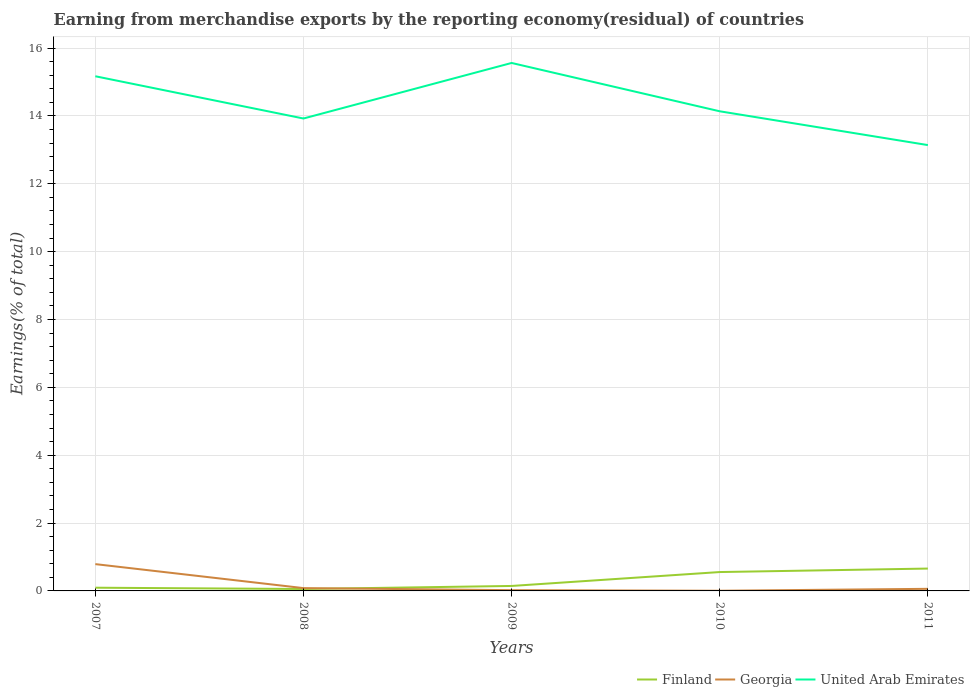How many different coloured lines are there?
Ensure brevity in your answer.  3. Does the line corresponding to United Arab Emirates intersect with the line corresponding to Finland?
Your response must be concise. No. Across all years, what is the maximum percentage of amount earned from merchandise exports in Georgia?
Your answer should be compact. 0.01. What is the total percentage of amount earned from merchandise exports in United Arab Emirates in the graph?
Make the answer very short. 2.42. What is the difference between the highest and the second highest percentage of amount earned from merchandise exports in Finland?
Make the answer very short. 0.6. How many lines are there?
Ensure brevity in your answer.  3. Are the values on the major ticks of Y-axis written in scientific E-notation?
Offer a terse response. No. Does the graph contain any zero values?
Your answer should be very brief. No. Does the graph contain grids?
Offer a very short reply. Yes. Where does the legend appear in the graph?
Make the answer very short. Bottom right. How are the legend labels stacked?
Ensure brevity in your answer.  Horizontal. What is the title of the graph?
Your answer should be very brief. Earning from merchandise exports by the reporting economy(residual) of countries. Does "Andorra" appear as one of the legend labels in the graph?
Ensure brevity in your answer.  No. What is the label or title of the Y-axis?
Your answer should be very brief. Earnings(% of total). What is the Earnings(% of total) of Finland in 2007?
Offer a terse response. 0.09. What is the Earnings(% of total) of Georgia in 2007?
Provide a succinct answer. 0.79. What is the Earnings(% of total) in United Arab Emirates in 2007?
Make the answer very short. 15.17. What is the Earnings(% of total) of Finland in 2008?
Provide a short and direct response. 0.06. What is the Earnings(% of total) in Georgia in 2008?
Your response must be concise. 0.08. What is the Earnings(% of total) in United Arab Emirates in 2008?
Give a very brief answer. 13.92. What is the Earnings(% of total) of Finland in 2009?
Your answer should be compact. 0.15. What is the Earnings(% of total) of Georgia in 2009?
Give a very brief answer. 0.02. What is the Earnings(% of total) of United Arab Emirates in 2009?
Your answer should be compact. 15.56. What is the Earnings(% of total) in Finland in 2010?
Ensure brevity in your answer.  0.56. What is the Earnings(% of total) of Georgia in 2010?
Ensure brevity in your answer.  0.01. What is the Earnings(% of total) in United Arab Emirates in 2010?
Give a very brief answer. 14.14. What is the Earnings(% of total) in Finland in 2011?
Offer a very short reply. 0.66. What is the Earnings(% of total) in Georgia in 2011?
Your answer should be very brief. 0.06. What is the Earnings(% of total) in United Arab Emirates in 2011?
Make the answer very short. 13.14. Across all years, what is the maximum Earnings(% of total) in Finland?
Give a very brief answer. 0.66. Across all years, what is the maximum Earnings(% of total) in Georgia?
Make the answer very short. 0.79. Across all years, what is the maximum Earnings(% of total) in United Arab Emirates?
Make the answer very short. 15.56. Across all years, what is the minimum Earnings(% of total) in Finland?
Keep it short and to the point. 0.06. Across all years, what is the minimum Earnings(% of total) in Georgia?
Keep it short and to the point. 0.01. Across all years, what is the minimum Earnings(% of total) of United Arab Emirates?
Offer a terse response. 13.14. What is the total Earnings(% of total) in Finland in the graph?
Keep it short and to the point. 1.51. What is the total Earnings(% of total) in Georgia in the graph?
Give a very brief answer. 0.96. What is the total Earnings(% of total) of United Arab Emirates in the graph?
Give a very brief answer. 71.92. What is the difference between the Earnings(% of total) in Finland in 2007 and that in 2008?
Give a very brief answer. 0.04. What is the difference between the Earnings(% of total) of Georgia in 2007 and that in 2008?
Your response must be concise. 0.71. What is the difference between the Earnings(% of total) in United Arab Emirates in 2007 and that in 2008?
Provide a succinct answer. 1.25. What is the difference between the Earnings(% of total) of Finland in 2007 and that in 2009?
Provide a short and direct response. -0.05. What is the difference between the Earnings(% of total) of Georgia in 2007 and that in 2009?
Provide a succinct answer. 0.77. What is the difference between the Earnings(% of total) in United Arab Emirates in 2007 and that in 2009?
Give a very brief answer. -0.39. What is the difference between the Earnings(% of total) in Finland in 2007 and that in 2010?
Your answer should be very brief. -0.46. What is the difference between the Earnings(% of total) of Georgia in 2007 and that in 2010?
Your answer should be compact. 0.78. What is the difference between the Earnings(% of total) of United Arab Emirates in 2007 and that in 2010?
Make the answer very short. 1.03. What is the difference between the Earnings(% of total) of Finland in 2007 and that in 2011?
Ensure brevity in your answer.  -0.56. What is the difference between the Earnings(% of total) in Georgia in 2007 and that in 2011?
Offer a terse response. 0.73. What is the difference between the Earnings(% of total) of United Arab Emirates in 2007 and that in 2011?
Your answer should be compact. 2.03. What is the difference between the Earnings(% of total) of Finland in 2008 and that in 2009?
Your answer should be compact. -0.09. What is the difference between the Earnings(% of total) of Georgia in 2008 and that in 2009?
Keep it short and to the point. 0.06. What is the difference between the Earnings(% of total) of United Arab Emirates in 2008 and that in 2009?
Your answer should be very brief. -1.64. What is the difference between the Earnings(% of total) of Finland in 2008 and that in 2010?
Your answer should be very brief. -0.5. What is the difference between the Earnings(% of total) in Georgia in 2008 and that in 2010?
Provide a short and direct response. 0.08. What is the difference between the Earnings(% of total) of United Arab Emirates in 2008 and that in 2010?
Provide a short and direct response. -0.21. What is the difference between the Earnings(% of total) of Finland in 2008 and that in 2011?
Give a very brief answer. -0.6. What is the difference between the Earnings(% of total) in Georgia in 2008 and that in 2011?
Provide a short and direct response. 0.02. What is the difference between the Earnings(% of total) of United Arab Emirates in 2008 and that in 2011?
Offer a terse response. 0.78. What is the difference between the Earnings(% of total) of Finland in 2009 and that in 2010?
Make the answer very short. -0.41. What is the difference between the Earnings(% of total) in Georgia in 2009 and that in 2010?
Your answer should be very brief. 0.02. What is the difference between the Earnings(% of total) of United Arab Emirates in 2009 and that in 2010?
Your response must be concise. 1.42. What is the difference between the Earnings(% of total) in Finland in 2009 and that in 2011?
Your answer should be very brief. -0.51. What is the difference between the Earnings(% of total) of Georgia in 2009 and that in 2011?
Offer a very short reply. -0.04. What is the difference between the Earnings(% of total) of United Arab Emirates in 2009 and that in 2011?
Offer a very short reply. 2.42. What is the difference between the Earnings(% of total) of Finland in 2010 and that in 2011?
Keep it short and to the point. -0.1. What is the difference between the Earnings(% of total) of Georgia in 2010 and that in 2011?
Give a very brief answer. -0.06. What is the difference between the Earnings(% of total) in Finland in 2007 and the Earnings(% of total) in Georgia in 2008?
Offer a terse response. 0.01. What is the difference between the Earnings(% of total) in Finland in 2007 and the Earnings(% of total) in United Arab Emirates in 2008?
Provide a succinct answer. -13.83. What is the difference between the Earnings(% of total) of Georgia in 2007 and the Earnings(% of total) of United Arab Emirates in 2008?
Your answer should be compact. -13.13. What is the difference between the Earnings(% of total) of Finland in 2007 and the Earnings(% of total) of Georgia in 2009?
Offer a terse response. 0.07. What is the difference between the Earnings(% of total) of Finland in 2007 and the Earnings(% of total) of United Arab Emirates in 2009?
Provide a succinct answer. -15.46. What is the difference between the Earnings(% of total) of Georgia in 2007 and the Earnings(% of total) of United Arab Emirates in 2009?
Your answer should be very brief. -14.77. What is the difference between the Earnings(% of total) of Finland in 2007 and the Earnings(% of total) of Georgia in 2010?
Give a very brief answer. 0.09. What is the difference between the Earnings(% of total) in Finland in 2007 and the Earnings(% of total) in United Arab Emirates in 2010?
Keep it short and to the point. -14.04. What is the difference between the Earnings(% of total) in Georgia in 2007 and the Earnings(% of total) in United Arab Emirates in 2010?
Make the answer very short. -13.35. What is the difference between the Earnings(% of total) of Finland in 2007 and the Earnings(% of total) of Georgia in 2011?
Provide a succinct answer. 0.03. What is the difference between the Earnings(% of total) in Finland in 2007 and the Earnings(% of total) in United Arab Emirates in 2011?
Your answer should be compact. -13.04. What is the difference between the Earnings(% of total) in Georgia in 2007 and the Earnings(% of total) in United Arab Emirates in 2011?
Ensure brevity in your answer.  -12.35. What is the difference between the Earnings(% of total) of Finland in 2008 and the Earnings(% of total) of Georgia in 2009?
Provide a short and direct response. 0.03. What is the difference between the Earnings(% of total) of Finland in 2008 and the Earnings(% of total) of United Arab Emirates in 2009?
Provide a succinct answer. -15.5. What is the difference between the Earnings(% of total) in Georgia in 2008 and the Earnings(% of total) in United Arab Emirates in 2009?
Keep it short and to the point. -15.48. What is the difference between the Earnings(% of total) in Finland in 2008 and the Earnings(% of total) in Georgia in 2010?
Make the answer very short. 0.05. What is the difference between the Earnings(% of total) in Finland in 2008 and the Earnings(% of total) in United Arab Emirates in 2010?
Your answer should be compact. -14.08. What is the difference between the Earnings(% of total) in Georgia in 2008 and the Earnings(% of total) in United Arab Emirates in 2010?
Your answer should be compact. -14.05. What is the difference between the Earnings(% of total) of Finland in 2008 and the Earnings(% of total) of Georgia in 2011?
Provide a succinct answer. -0.01. What is the difference between the Earnings(% of total) in Finland in 2008 and the Earnings(% of total) in United Arab Emirates in 2011?
Keep it short and to the point. -13.08. What is the difference between the Earnings(% of total) in Georgia in 2008 and the Earnings(% of total) in United Arab Emirates in 2011?
Keep it short and to the point. -13.06. What is the difference between the Earnings(% of total) in Finland in 2009 and the Earnings(% of total) in Georgia in 2010?
Your response must be concise. 0.14. What is the difference between the Earnings(% of total) in Finland in 2009 and the Earnings(% of total) in United Arab Emirates in 2010?
Your answer should be very brief. -13.99. What is the difference between the Earnings(% of total) in Georgia in 2009 and the Earnings(% of total) in United Arab Emirates in 2010?
Your answer should be compact. -14.11. What is the difference between the Earnings(% of total) in Finland in 2009 and the Earnings(% of total) in Georgia in 2011?
Offer a very short reply. 0.08. What is the difference between the Earnings(% of total) in Finland in 2009 and the Earnings(% of total) in United Arab Emirates in 2011?
Your answer should be very brief. -12.99. What is the difference between the Earnings(% of total) of Georgia in 2009 and the Earnings(% of total) of United Arab Emirates in 2011?
Offer a terse response. -13.12. What is the difference between the Earnings(% of total) in Finland in 2010 and the Earnings(% of total) in Georgia in 2011?
Ensure brevity in your answer.  0.49. What is the difference between the Earnings(% of total) in Finland in 2010 and the Earnings(% of total) in United Arab Emirates in 2011?
Ensure brevity in your answer.  -12.58. What is the difference between the Earnings(% of total) of Georgia in 2010 and the Earnings(% of total) of United Arab Emirates in 2011?
Make the answer very short. -13.13. What is the average Earnings(% of total) in Finland per year?
Your answer should be compact. 0.3. What is the average Earnings(% of total) in Georgia per year?
Provide a succinct answer. 0.19. What is the average Earnings(% of total) in United Arab Emirates per year?
Give a very brief answer. 14.38. In the year 2007, what is the difference between the Earnings(% of total) in Finland and Earnings(% of total) in Georgia?
Your answer should be very brief. -0.7. In the year 2007, what is the difference between the Earnings(% of total) in Finland and Earnings(% of total) in United Arab Emirates?
Give a very brief answer. -15.07. In the year 2007, what is the difference between the Earnings(% of total) in Georgia and Earnings(% of total) in United Arab Emirates?
Provide a short and direct response. -14.38. In the year 2008, what is the difference between the Earnings(% of total) in Finland and Earnings(% of total) in Georgia?
Offer a very short reply. -0.03. In the year 2008, what is the difference between the Earnings(% of total) in Finland and Earnings(% of total) in United Arab Emirates?
Give a very brief answer. -13.87. In the year 2008, what is the difference between the Earnings(% of total) of Georgia and Earnings(% of total) of United Arab Emirates?
Give a very brief answer. -13.84. In the year 2009, what is the difference between the Earnings(% of total) in Finland and Earnings(% of total) in Georgia?
Offer a very short reply. 0.12. In the year 2009, what is the difference between the Earnings(% of total) in Finland and Earnings(% of total) in United Arab Emirates?
Provide a succinct answer. -15.41. In the year 2009, what is the difference between the Earnings(% of total) in Georgia and Earnings(% of total) in United Arab Emirates?
Ensure brevity in your answer.  -15.54. In the year 2010, what is the difference between the Earnings(% of total) of Finland and Earnings(% of total) of Georgia?
Your response must be concise. 0.55. In the year 2010, what is the difference between the Earnings(% of total) of Finland and Earnings(% of total) of United Arab Emirates?
Ensure brevity in your answer.  -13.58. In the year 2010, what is the difference between the Earnings(% of total) of Georgia and Earnings(% of total) of United Arab Emirates?
Make the answer very short. -14.13. In the year 2011, what is the difference between the Earnings(% of total) of Finland and Earnings(% of total) of Georgia?
Make the answer very short. 0.6. In the year 2011, what is the difference between the Earnings(% of total) in Finland and Earnings(% of total) in United Arab Emirates?
Give a very brief answer. -12.48. In the year 2011, what is the difference between the Earnings(% of total) of Georgia and Earnings(% of total) of United Arab Emirates?
Ensure brevity in your answer.  -13.08. What is the ratio of the Earnings(% of total) in Finland in 2007 to that in 2008?
Provide a succinct answer. 1.68. What is the ratio of the Earnings(% of total) of Georgia in 2007 to that in 2008?
Give a very brief answer. 9.53. What is the ratio of the Earnings(% of total) in United Arab Emirates in 2007 to that in 2008?
Provide a short and direct response. 1.09. What is the ratio of the Earnings(% of total) of Finland in 2007 to that in 2009?
Offer a terse response. 0.65. What is the ratio of the Earnings(% of total) of Georgia in 2007 to that in 2009?
Offer a terse response. 34.8. What is the ratio of the Earnings(% of total) in United Arab Emirates in 2007 to that in 2009?
Ensure brevity in your answer.  0.97. What is the ratio of the Earnings(% of total) of Finland in 2007 to that in 2010?
Offer a terse response. 0.17. What is the ratio of the Earnings(% of total) of Georgia in 2007 to that in 2010?
Offer a terse response. 140.46. What is the ratio of the Earnings(% of total) in United Arab Emirates in 2007 to that in 2010?
Give a very brief answer. 1.07. What is the ratio of the Earnings(% of total) in Finland in 2007 to that in 2011?
Offer a terse response. 0.14. What is the ratio of the Earnings(% of total) in Georgia in 2007 to that in 2011?
Make the answer very short. 12.8. What is the ratio of the Earnings(% of total) of United Arab Emirates in 2007 to that in 2011?
Provide a succinct answer. 1.15. What is the ratio of the Earnings(% of total) in Finland in 2008 to that in 2009?
Offer a very short reply. 0.38. What is the ratio of the Earnings(% of total) in Georgia in 2008 to that in 2009?
Offer a terse response. 3.65. What is the ratio of the Earnings(% of total) in United Arab Emirates in 2008 to that in 2009?
Ensure brevity in your answer.  0.89. What is the ratio of the Earnings(% of total) of Finland in 2008 to that in 2010?
Give a very brief answer. 0.1. What is the ratio of the Earnings(% of total) in Georgia in 2008 to that in 2010?
Provide a succinct answer. 14.74. What is the ratio of the Earnings(% of total) of United Arab Emirates in 2008 to that in 2010?
Offer a terse response. 0.98. What is the ratio of the Earnings(% of total) of Finland in 2008 to that in 2011?
Your answer should be compact. 0.09. What is the ratio of the Earnings(% of total) of Georgia in 2008 to that in 2011?
Your response must be concise. 1.34. What is the ratio of the Earnings(% of total) of United Arab Emirates in 2008 to that in 2011?
Offer a terse response. 1.06. What is the ratio of the Earnings(% of total) in Finland in 2009 to that in 2010?
Offer a terse response. 0.26. What is the ratio of the Earnings(% of total) of Georgia in 2009 to that in 2010?
Provide a short and direct response. 4.04. What is the ratio of the Earnings(% of total) of United Arab Emirates in 2009 to that in 2010?
Your answer should be compact. 1.1. What is the ratio of the Earnings(% of total) of Finland in 2009 to that in 2011?
Offer a terse response. 0.22. What is the ratio of the Earnings(% of total) of Georgia in 2009 to that in 2011?
Keep it short and to the point. 0.37. What is the ratio of the Earnings(% of total) of United Arab Emirates in 2009 to that in 2011?
Ensure brevity in your answer.  1.18. What is the ratio of the Earnings(% of total) in Finland in 2010 to that in 2011?
Keep it short and to the point. 0.84. What is the ratio of the Earnings(% of total) in Georgia in 2010 to that in 2011?
Your response must be concise. 0.09. What is the ratio of the Earnings(% of total) of United Arab Emirates in 2010 to that in 2011?
Your response must be concise. 1.08. What is the difference between the highest and the second highest Earnings(% of total) in Finland?
Make the answer very short. 0.1. What is the difference between the highest and the second highest Earnings(% of total) of Georgia?
Provide a succinct answer. 0.71. What is the difference between the highest and the second highest Earnings(% of total) of United Arab Emirates?
Offer a terse response. 0.39. What is the difference between the highest and the lowest Earnings(% of total) in Finland?
Offer a terse response. 0.6. What is the difference between the highest and the lowest Earnings(% of total) in Georgia?
Offer a terse response. 0.78. What is the difference between the highest and the lowest Earnings(% of total) in United Arab Emirates?
Provide a short and direct response. 2.42. 